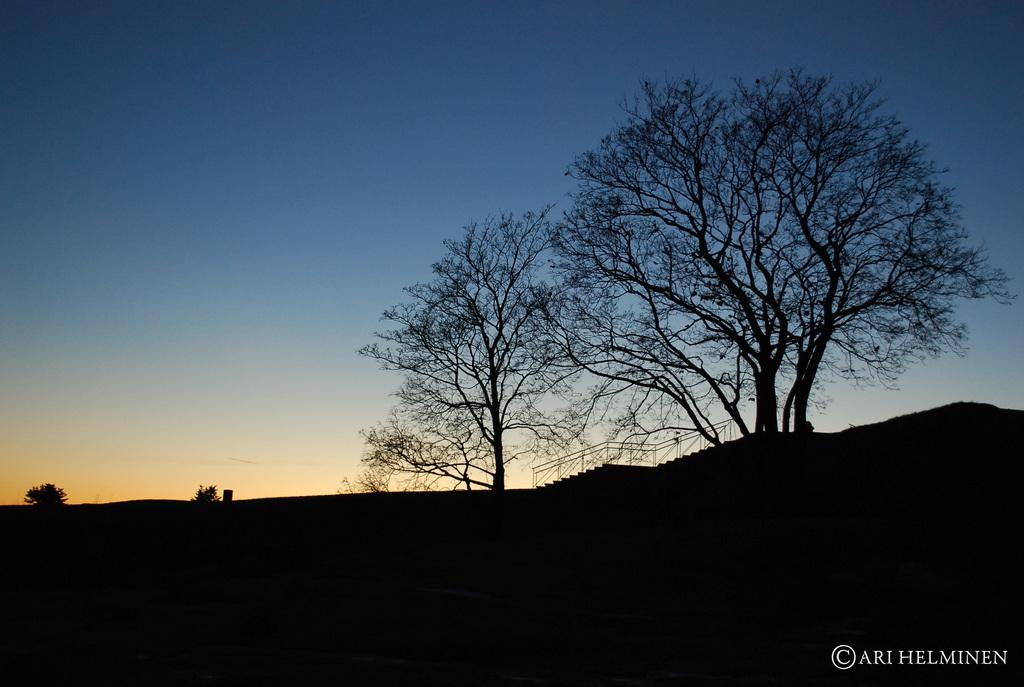What type of vegetation can be seen in the image? There are trees in the image. Where are the trees located? The trees are on land. What architectural feature is present on the right side of the image? There are steps on the right side of the image. What is visible above the trees in the image? The sky is visible above the trees. How many tickets are needed to access the comfort provided by the trees in the image? There are no tickets or comfort-related elements present in the image; it simply features trees on land with steps nearby and the sky visible above. 